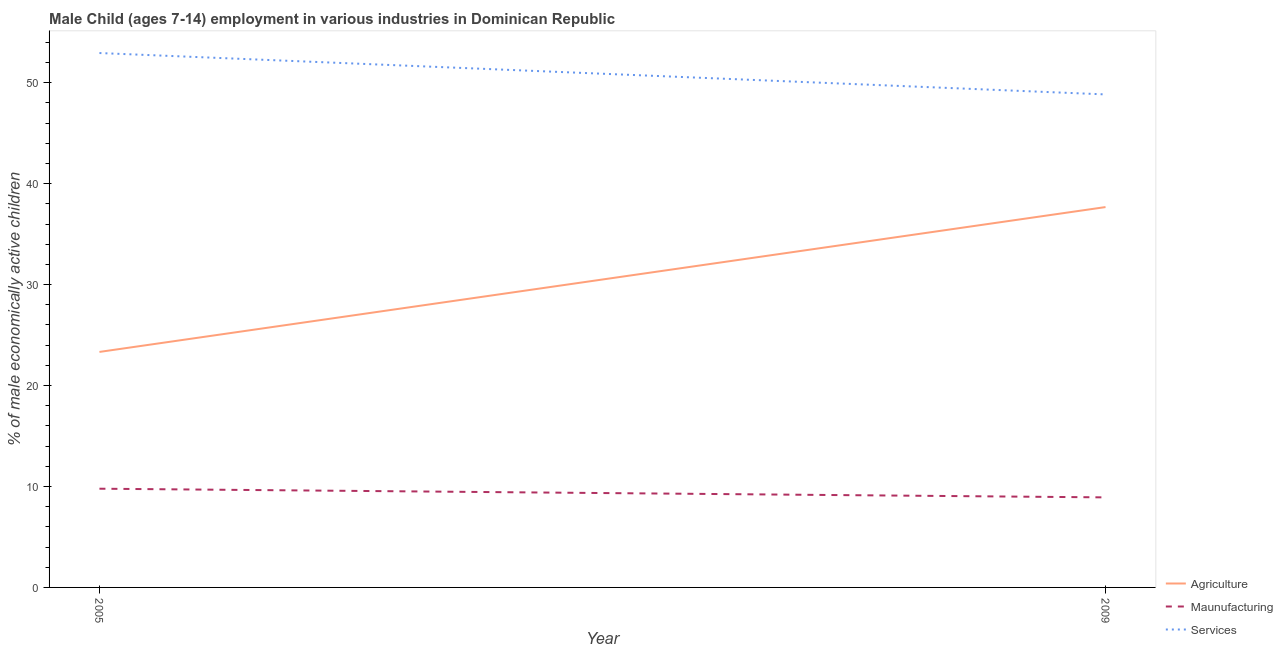What is the percentage of economically active children in services in 2005?
Provide a succinct answer. 52.94. Across all years, what is the maximum percentage of economically active children in manufacturing?
Provide a short and direct response. 9.78. Across all years, what is the minimum percentage of economically active children in services?
Offer a terse response. 48.84. In which year was the percentage of economically active children in agriculture minimum?
Ensure brevity in your answer.  2005. What is the difference between the percentage of economically active children in agriculture in 2005 and that in 2009?
Provide a short and direct response. -14.35. What is the difference between the percentage of economically active children in agriculture in 2005 and the percentage of economically active children in manufacturing in 2009?
Provide a succinct answer. 14.41. What is the average percentage of economically active children in services per year?
Give a very brief answer. 50.89. In the year 2005, what is the difference between the percentage of economically active children in agriculture and percentage of economically active children in services?
Your answer should be very brief. -29.61. In how many years, is the percentage of economically active children in manufacturing greater than 26 %?
Keep it short and to the point. 0. What is the ratio of the percentage of economically active children in services in 2005 to that in 2009?
Give a very brief answer. 1.08. Is the percentage of economically active children in agriculture in 2005 less than that in 2009?
Provide a short and direct response. Yes. Does the percentage of economically active children in agriculture monotonically increase over the years?
Offer a very short reply. Yes. Is the percentage of economically active children in manufacturing strictly greater than the percentage of economically active children in agriculture over the years?
Offer a terse response. No. How many lines are there?
Your response must be concise. 3. What is the difference between two consecutive major ticks on the Y-axis?
Give a very brief answer. 10. Where does the legend appear in the graph?
Ensure brevity in your answer.  Bottom right. How many legend labels are there?
Give a very brief answer. 3. What is the title of the graph?
Ensure brevity in your answer.  Male Child (ages 7-14) employment in various industries in Dominican Republic. What is the label or title of the X-axis?
Give a very brief answer. Year. What is the label or title of the Y-axis?
Make the answer very short. % of male economically active children. What is the % of male economically active children of Agriculture in 2005?
Provide a succinct answer. 23.33. What is the % of male economically active children of Maunufacturing in 2005?
Your answer should be very brief. 9.78. What is the % of male economically active children of Services in 2005?
Make the answer very short. 52.94. What is the % of male economically active children of Agriculture in 2009?
Offer a terse response. 37.68. What is the % of male economically active children in Maunufacturing in 2009?
Offer a very short reply. 8.92. What is the % of male economically active children of Services in 2009?
Your answer should be very brief. 48.84. Across all years, what is the maximum % of male economically active children of Agriculture?
Provide a succinct answer. 37.68. Across all years, what is the maximum % of male economically active children in Maunufacturing?
Make the answer very short. 9.78. Across all years, what is the maximum % of male economically active children in Services?
Keep it short and to the point. 52.94. Across all years, what is the minimum % of male economically active children of Agriculture?
Offer a very short reply. 23.33. Across all years, what is the minimum % of male economically active children in Maunufacturing?
Keep it short and to the point. 8.92. Across all years, what is the minimum % of male economically active children of Services?
Offer a terse response. 48.84. What is the total % of male economically active children of Agriculture in the graph?
Ensure brevity in your answer.  61.01. What is the total % of male economically active children of Maunufacturing in the graph?
Your answer should be compact. 18.7. What is the total % of male economically active children in Services in the graph?
Your response must be concise. 101.78. What is the difference between the % of male economically active children in Agriculture in 2005 and that in 2009?
Offer a terse response. -14.35. What is the difference between the % of male economically active children in Maunufacturing in 2005 and that in 2009?
Offer a very short reply. 0.86. What is the difference between the % of male economically active children in Services in 2005 and that in 2009?
Provide a succinct answer. 4.1. What is the difference between the % of male economically active children of Agriculture in 2005 and the % of male economically active children of Maunufacturing in 2009?
Provide a succinct answer. 14.41. What is the difference between the % of male economically active children of Agriculture in 2005 and the % of male economically active children of Services in 2009?
Make the answer very short. -25.51. What is the difference between the % of male economically active children of Maunufacturing in 2005 and the % of male economically active children of Services in 2009?
Provide a short and direct response. -39.06. What is the average % of male economically active children of Agriculture per year?
Your answer should be compact. 30.5. What is the average % of male economically active children in Maunufacturing per year?
Keep it short and to the point. 9.35. What is the average % of male economically active children of Services per year?
Offer a terse response. 50.89. In the year 2005, what is the difference between the % of male economically active children in Agriculture and % of male economically active children in Maunufacturing?
Your answer should be compact. 13.55. In the year 2005, what is the difference between the % of male economically active children in Agriculture and % of male economically active children in Services?
Offer a terse response. -29.61. In the year 2005, what is the difference between the % of male economically active children in Maunufacturing and % of male economically active children in Services?
Make the answer very short. -43.16. In the year 2009, what is the difference between the % of male economically active children in Agriculture and % of male economically active children in Maunufacturing?
Give a very brief answer. 28.76. In the year 2009, what is the difference between the % of male economically active children of Agriculture and % of male economically active children of Services?
Make the answer very short. -11.16. In the year 2009, what is the difference between the % of male economically active children in Maunufacturing and % of male economically active children in Services?
Provide a short and direct response. -39.92. What is the ratio of the % of male economically active children of Agriculture in 2005 to that in 2009?
Offer a very short reply. 0.62. What is the ratio of the % of male economically active children in Maunufacturing in 2005 to that in 2009?
Your answer should be very brief. 1.1. What is the ratio of the % of male economically active children in Services in 2005 to that in 2009?
Your answer should be very brief. 1.08. What is the difference between the highest and the second highest % of male economically active children of Agriculture?
Provide a short and direct response. 14.35. What is the difference between the highest and the second highest % of male economically active children in Maunufacturing?
Your answer should be very brief. 0.86. What is the difference between the highest and the lowest % of male economically active children in Agriculture?
Offer a very short reply. 14.35. What is the difference between the highest and the lowest % of male economically active children of Maunufacturing?
Your answer should be very brief. 0.86. What is the difference between the highest and the lowest % of male economically active children in Services?
Offer a very short reply. 4.1. 